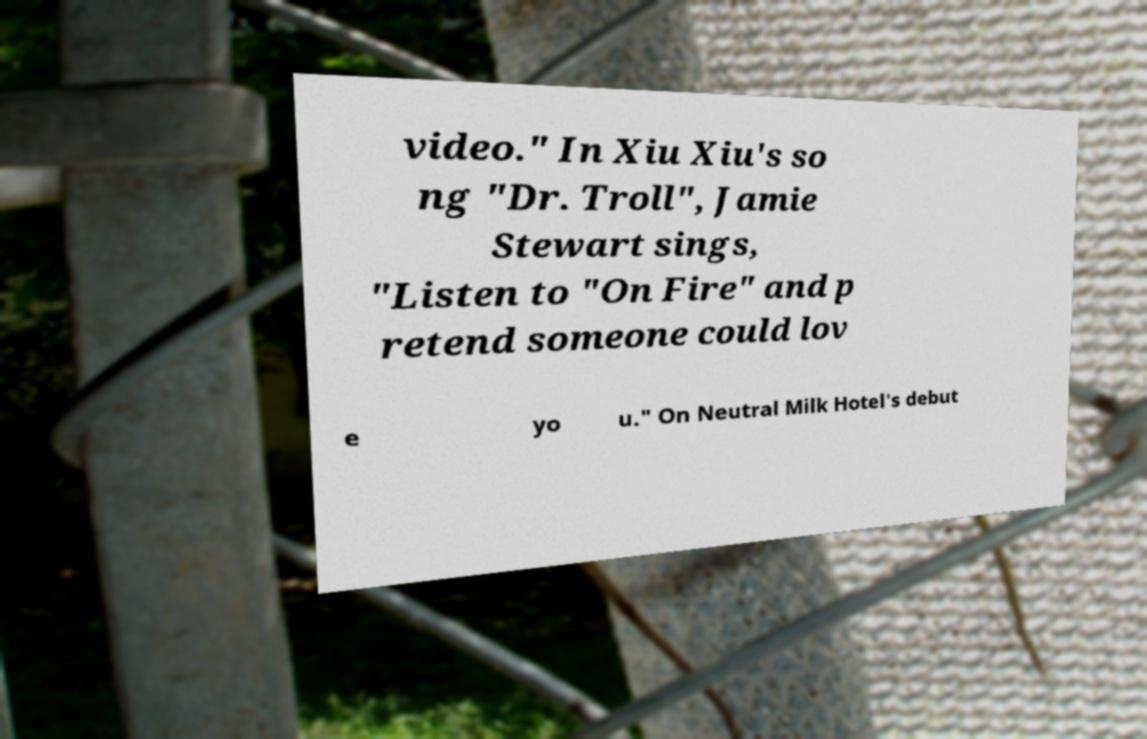I need the written content from this picture converted into text. Can you do that? video." In Xiu Xiu's so ng "Dr. Troll", Jamie Stewart sings, "Listen to "On Fire" and p retend someone could lov e yo u." On Neutral Milk Hotel's debut 